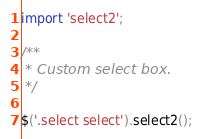<code> <loc_0><loc_0><loc_500><loc_500><_JavaScript_>
import 'select2';

/**
 * Custom select box.
 */

$('.select select').select2();
</code> 